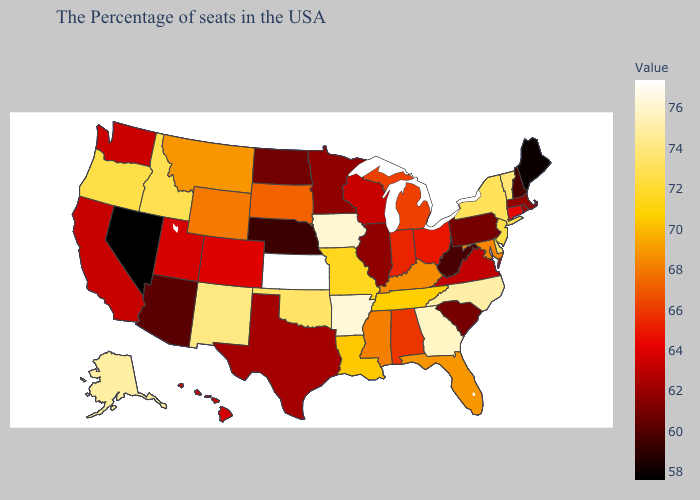Which states hav the highest value in the South?
Quick response, please. Arkansas. Does West Virginia have the lowest value in the South?
Be succinct. Yes. Does New Hampshire have a higher value than Wisconsin?
Answer briefly. No. Among the states that border Alabama , does Mississippi have the lowest value?
Answer briefly. Yes. Among the states that border Montana , does North Dakota have the lowest value?
Short answer required. Yes. Does Kansas have the highest value in the MidWest?
Concise answer only. Yes. Which states have the lowest value in the MidWest?
Write a very short answer. Nebraska. Does the map have missing data?
Answer briefly. No. Does Connecticut have the highest value in the USA?
Give a very brief answer. No. 